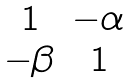Convert formula to latex. <formula><loc_0><loc_0><loc_500><loc_500>\begin{matrix} 1 & - \alpha \\ - \beta & 1 \end{matrix}</formula> 